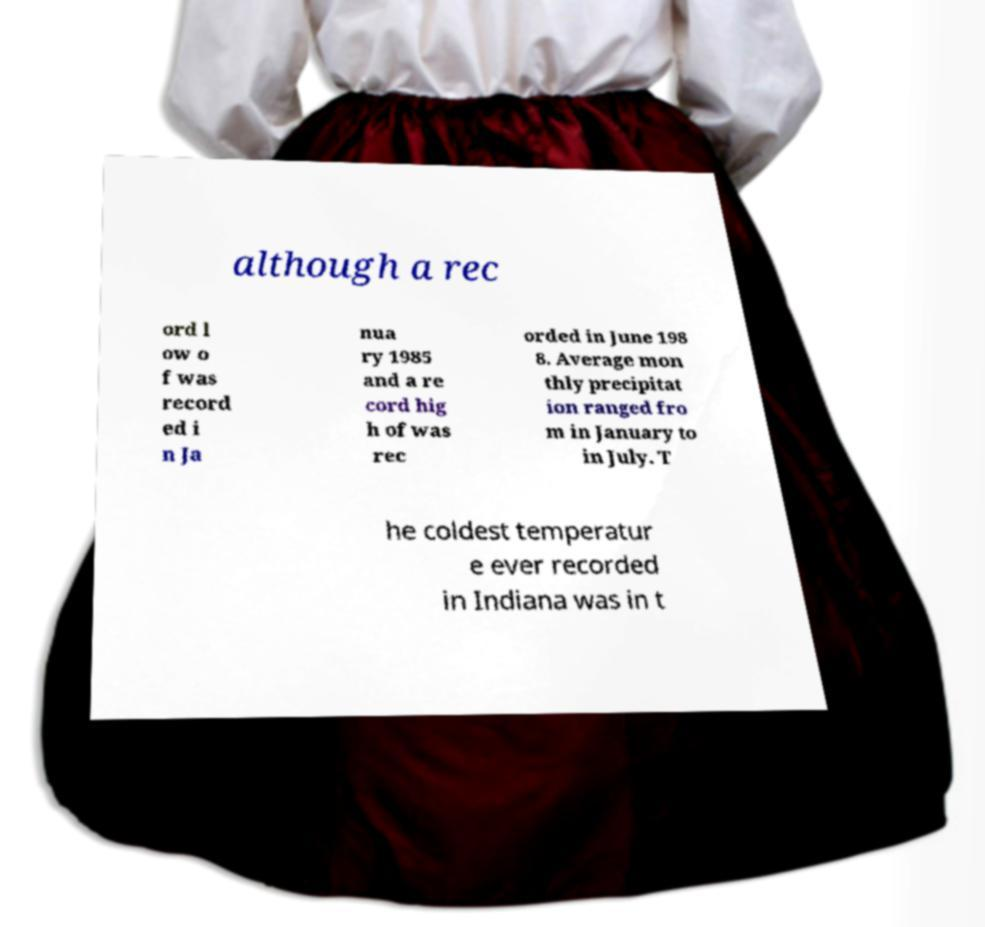Can you read and provide the text displayed in the image?This photo seems to have some interesting text. Can you extract and type it out for me? although a rec ord l ow o f was record ed i n Ja nua ry 1985 and a re cord hig h of was rec orded in June 198 8. Average mon thly precipitat ion ranged fro m in January to in July. T he coldest temperatur e ever recorded in Indiana was in t 